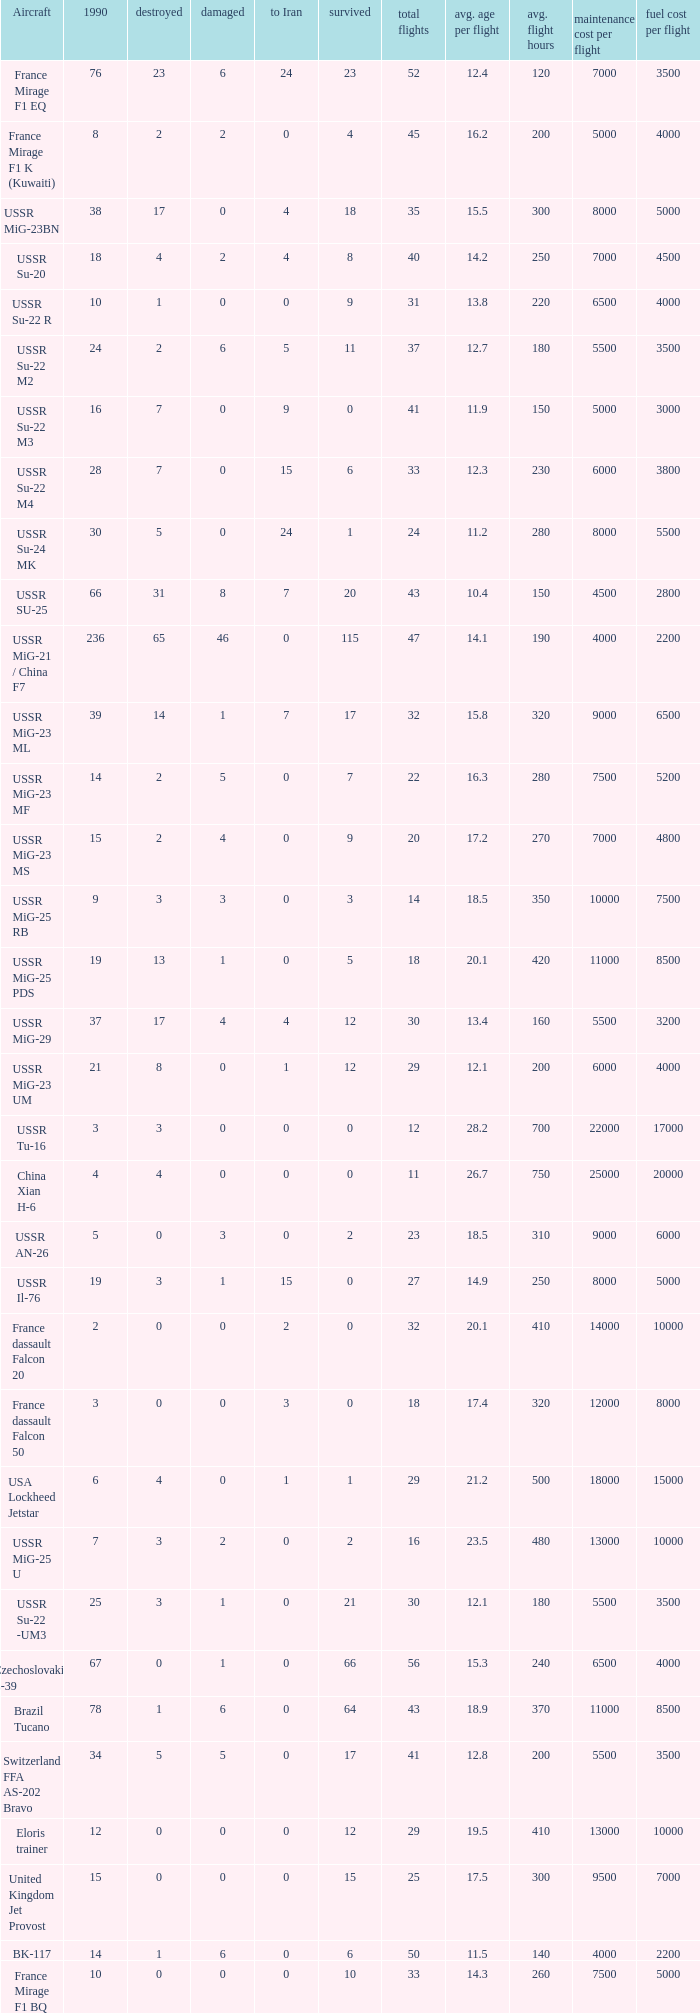If there were 14 in 1990 and 6 survived how many were destroyed? 1.0. 